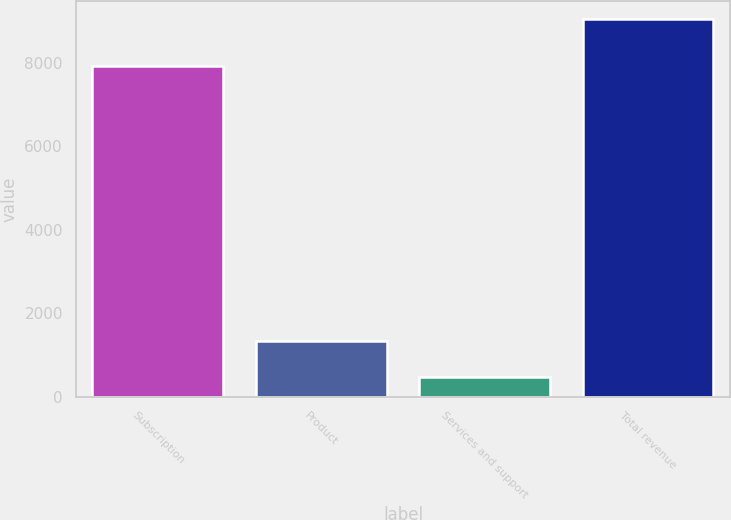Convert chart to OTSL. <chart><loc_0><loc_0><loc_500><loc_500><bar_chart><fcel>Subscription<fcel>Product<fcel>Services and support<fcel>Total revenue<nl><fcel>7922.2<fcel>1340.13<fcel>485.7<fcel>9030<nl></chart> 